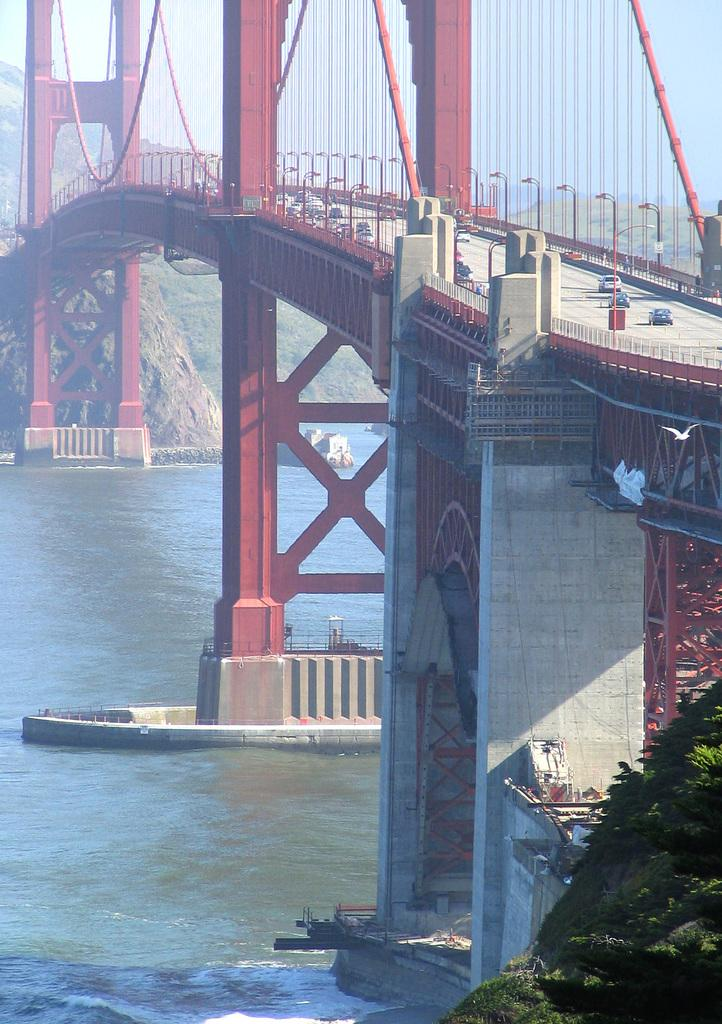What structure is present in the image? There is a bridge in the image. What color is the bridge? The bridge is red in color. What can be seen on the bridge? There are vehicles on the bridge. What is beneath the bridge? There is water below the bridge. What type of vegetation is visible in the image? There is greenery in the right corner of the image. What is the weight of the number visible on the bridge? There is no number visible on the bridge, and therefore no weight can be determined. 